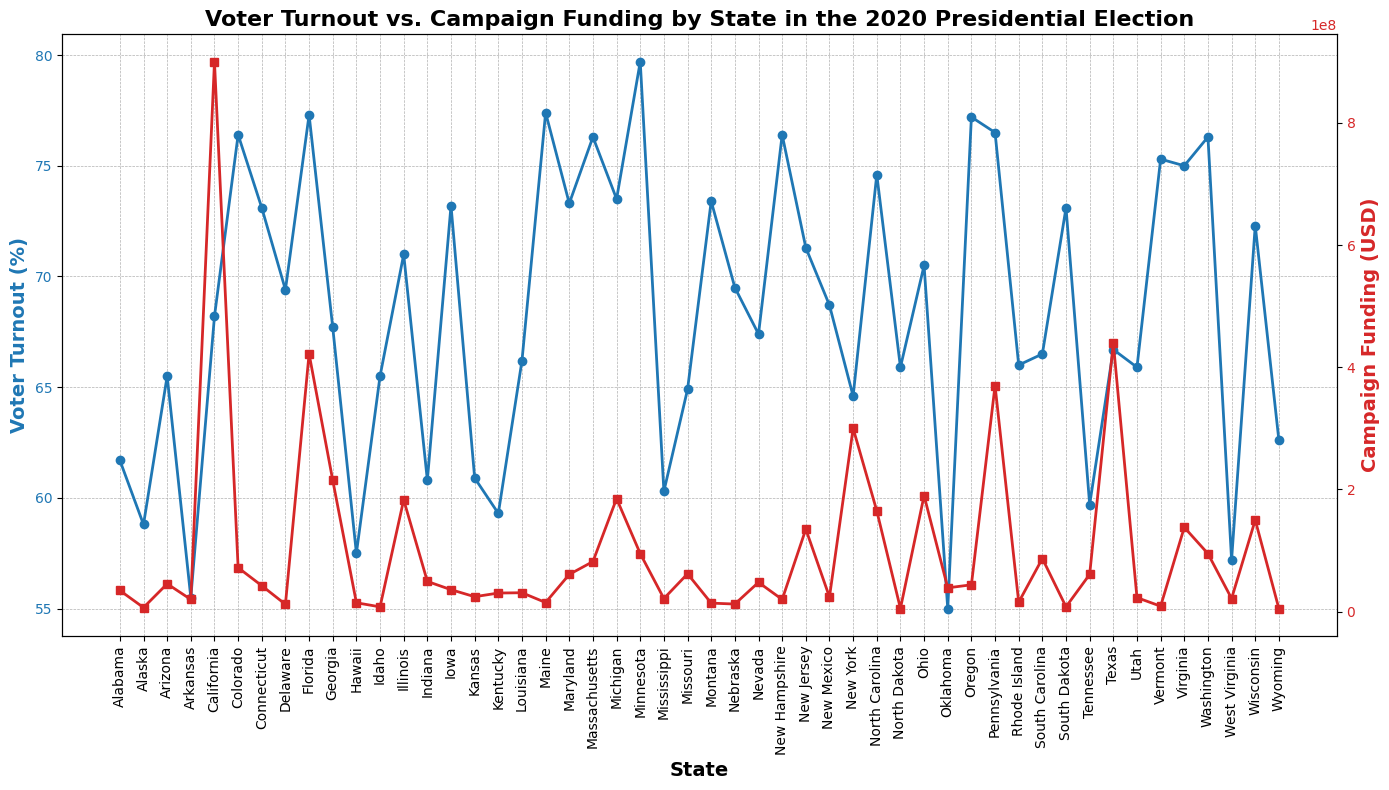Which state had the highest voter turnout percentage? Look at the blue line representing voter turnout and find the state with the highest marker.
Answer: Minnesota What is the difference in voter turnout percentage between Florida and New York? Reference the blue markers for Florida and New York, then subtract the lower value from the higher one. Florida has 77.3% and New York has 64.6%, so the difference is 77.3 - 64.6.
Answer: 12.7% Which state received the most campaign funding and what was the amount? Look for the highest red marker on the red line indicating campaign funding.
Answer: California, $900,000,000 How does the campaign funding in Georgia compare to that in Ohio? Compare the red markers for Georgia and Ohio. Georgia received $215,000,000 and Ohio received $190,000,000, so Georgia received more.
Answer: Georgia received more What is the average voter turnout percentage for states with turnout above 70%? Identify states with voter turnout percentages above 70% and calculate the mean of these percentages. These states include Florida, Maine, Vermont, Washington, Massachusetts, etc. First add up their percentages (77.3 + 77.4 + 75.3 + 76.3 + 76.4 + 71.0 + 73.1 + 73.5 + 72.3 + 74.6) = 747.2. There are 10 states, so divide the sum by 10.
Answer: 74.7% Which states had a voter turnout between 60% and 65% and what were their campaign funding amounts? Identify the blue markers between 60% and 65%. These states include Alabama, Alaska, Idaho, Missouri, North Dakota, Utah, Wyoming. Look at their corresponding red markers for campaign funding.
Answer: Alabama: $34,700,000; Alaska: $6,750,000; Idaho: $7,900,000; Missouri: $62,000,000; North Dakota: $5,200,000; Utah: $23,000,000; Wyoming: $5,000,000 What is the correlation between voter turnout and campaign funding? Visually assess the trend lines of voter turnout (blue) and campaign funding (red). While not precise, there is a general trend that states with high voter turnout tend to have higher campaign funding.
Answer: Positive correlation Which state with voter turnout below 60% received the highest amount of campaign funding? Look for blue markers below 60% and check their corresponding red markers. States under 60% are Oklahoma, West Virginia, Hawaii, Arkansas, Tennessee, Mississippi, Kentucky, Alaska. Among these, Tennessee received $61,000,000.
Answer: Tennessee 